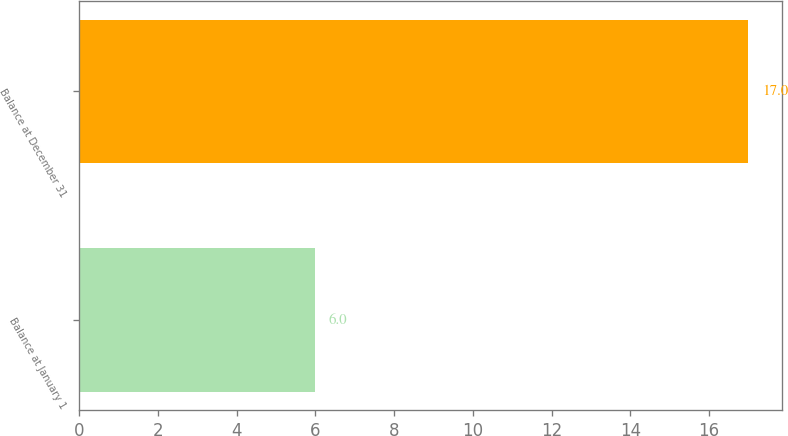Convert chart. <chart><loc_0><loc_0><loc_500><loc_500><bar_chart><fcel>Balance at January 1<fcel>Balance at December 31<nl><fcel>6<fcel>17<nl></chart> 